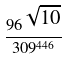<formula> <loc_0><loc_0><loc_500><loc_500>\frac { 9 6 ^ { \sqrt { 1 0 } } } { 3 0 9 ^ { 4 4 6 } }</formula> 